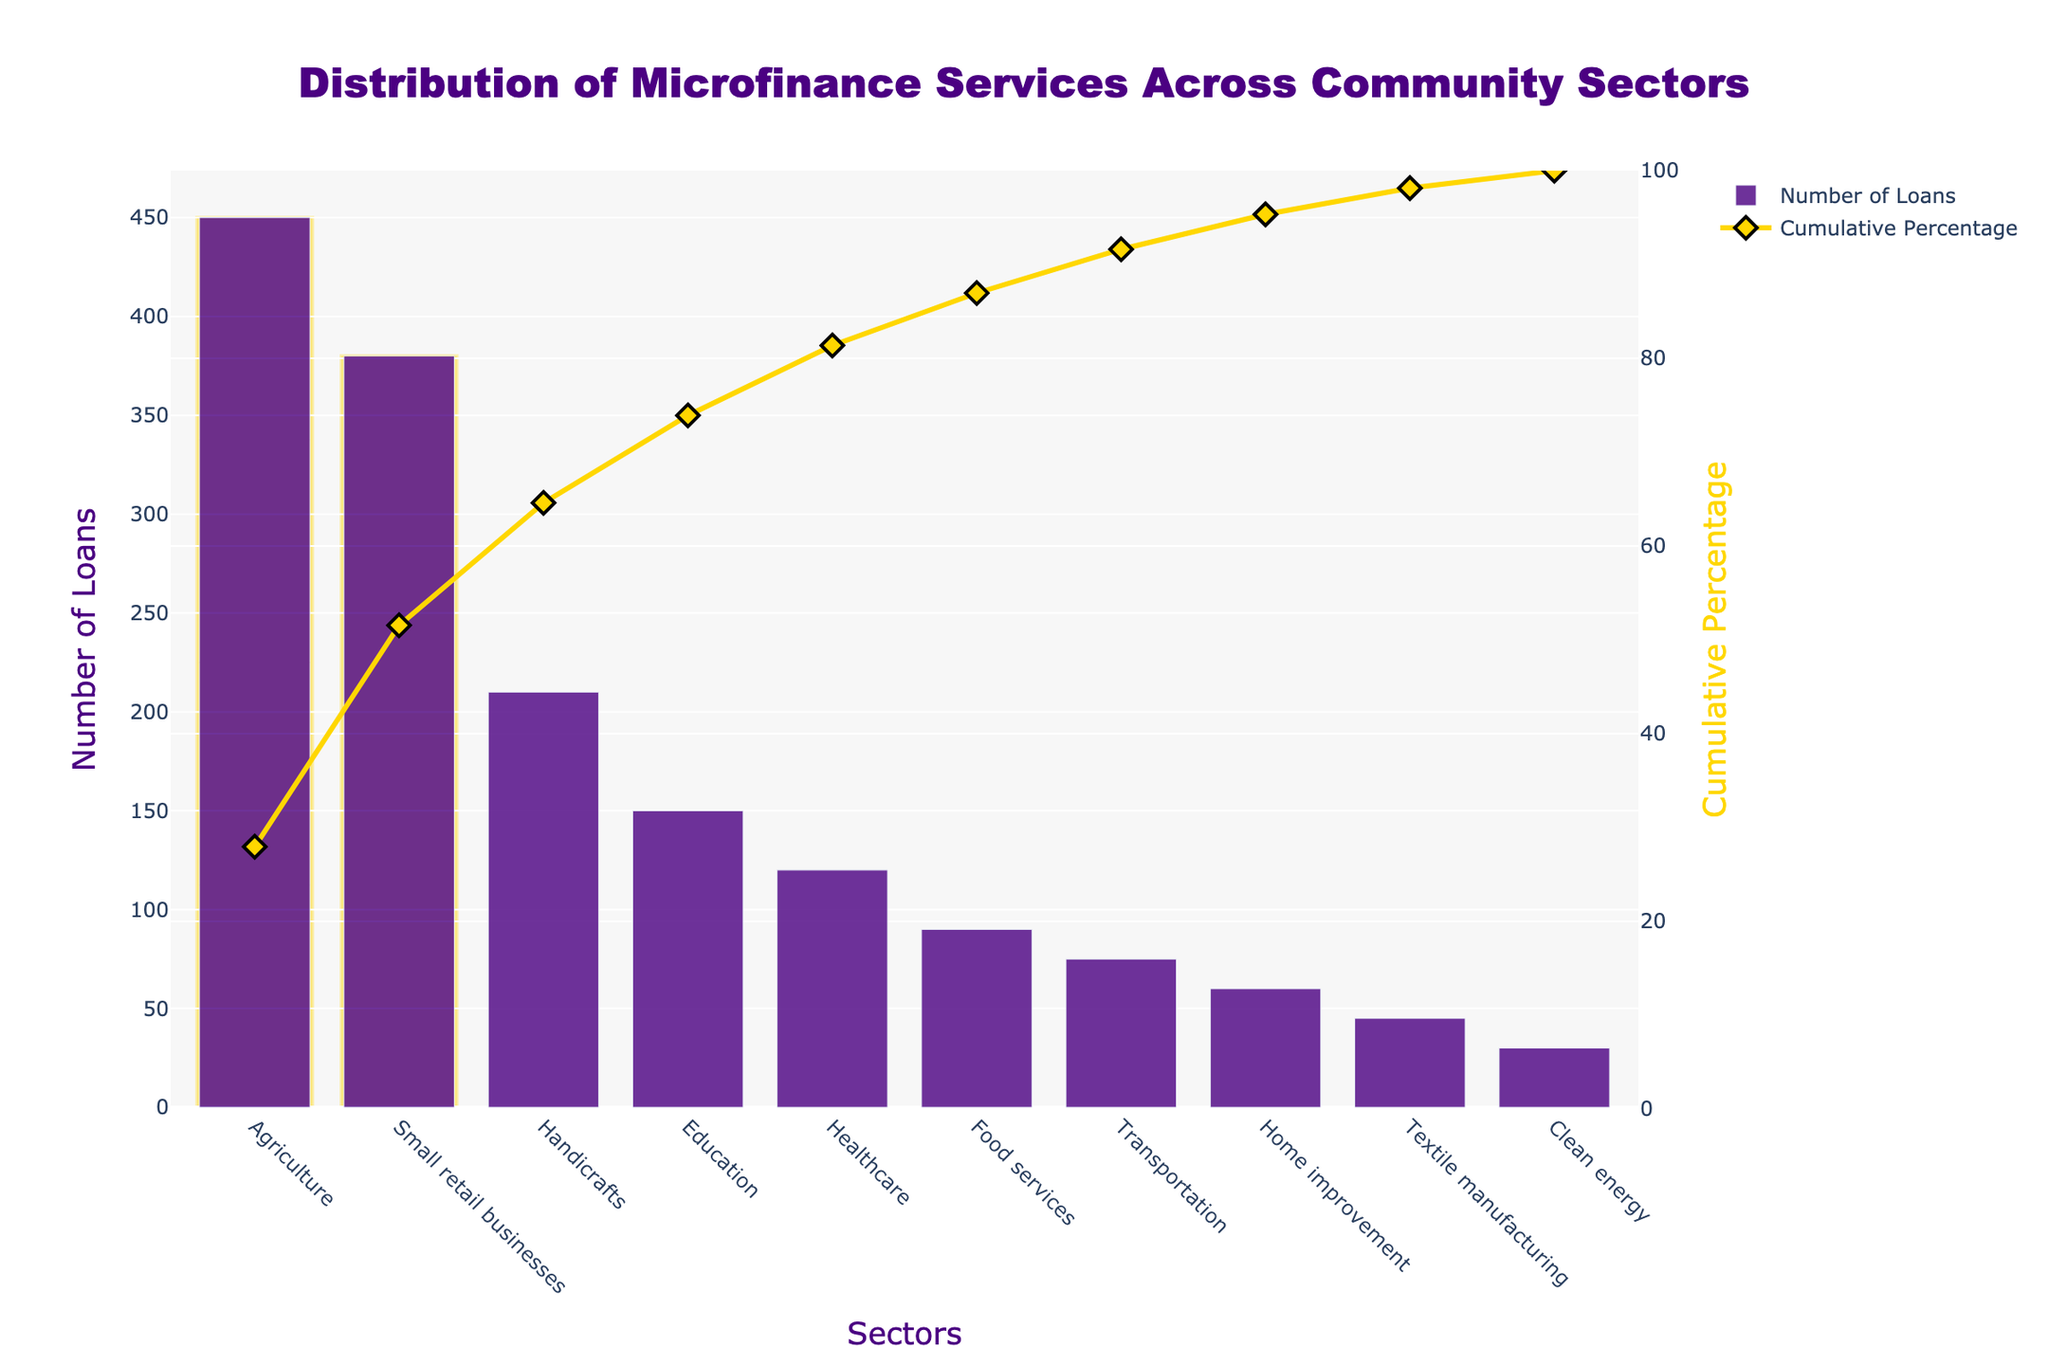What's the title of the chart? The title is located at the top of the chart and it reads "Distribution of Microfinance Services Across Community Sectors".
Answer: Distribution of Microfinance Services Across Community Sectors What sector has the highest number of loans? The sector with the highest bar represents the highest number of loans, which is Agriculture.
Answer: Agriculture What sectors are included in the top 20% of categories in terms of loans? The top 20% of sectors can be identified by the highlighted bars. There are 2 highlighted bars, which are Agriculture and Small retail businesses.
Answer: Agriculture and Small retail businesses What is the cumulative percentage of loans for agriculture alone? The diamond marker on the cumulative percentage line above the Agriculture bar indicates its cumulative percentage. It is around 20% absolute value calculation from the figure.
Answer: 20% What is the total number of loans distributed to both healthcare and food services sectors? Locate the bars for Healthcare and Food services sectors, and sum their loan numbers: 120 (Healthcare) + 90 (Food services).
Answer: 210 Which sector corresponds to the category with the lowest number of loans and what is that number? The lowest bar represents Clean energy sector with the smallest number of loans, which is 30.
Answer: Clean energy, 30 What is the cumulative percentage after the sum of loans from the top three sectors? Add the cumulative percentages for Agriculture, Small retail businesses, and Handicrafts: 20% (Agriculture) + 16% (Small retail businesses) + 9% (Handicrafts) which sums up to 45%.
Answer: 45% How many sectors have a number of loans greater than 100? Count the sectors whose bars extend beyond the 100 loan-mark on the y-axis, which includes Agriculture, Small retail businesses, Handicrafts, Education, and Healthcare.
Answer: 5 Which sector has the closest number of loans to Home improvement? The bar of Transportation is close in height to Home improvement, with numbers 75 and 60 respectively.
Answer: Transportation Compare the cumulative percentages for education and healthcare sectors. What is the difference between them? Healthcare cumulative percentage is at 76% - 60% (Education sector cumulative percentage) = 16%.
Answer: 16% 